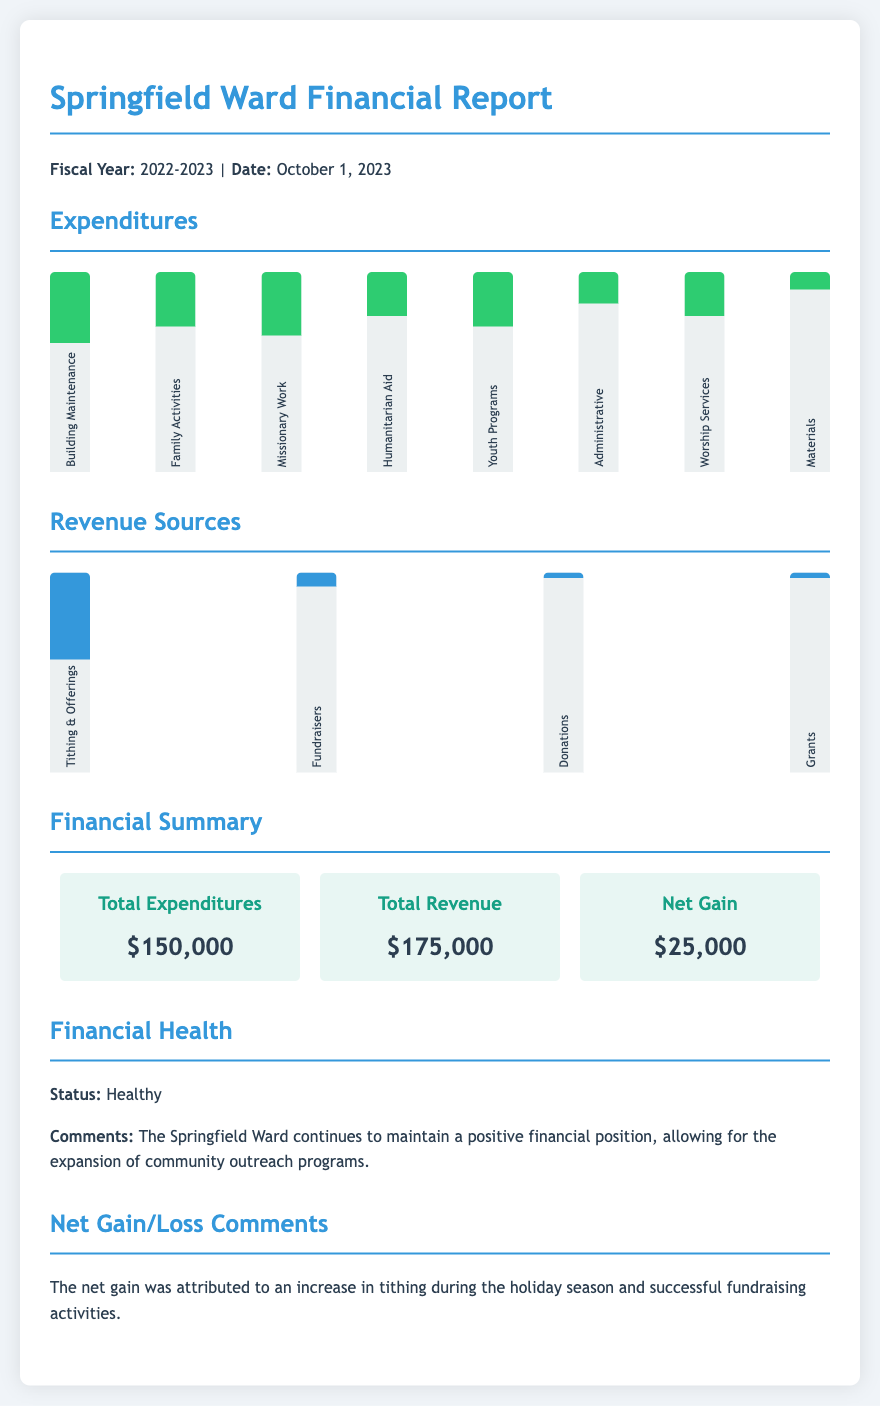What is the fiscal year of the report? The fiscal year is indicated in the document header, showing the period covered by the financial report.
Answer: 2022-2023 What were the total expenditures? The total expenditures are summarized in the financial summary section.
Answer: $150,000 What is the primary source of revenue? The highest revenue source is shown in the revenue sources chart.
Answer: Tithing & Offerings What percentage of the expenditures was spent on Building Maintenance? The chart details the percentage spent on Building Maintenance among other expenditures.
Answer: 60% What is the net gain reported? The net gain is calculated from the total revenue and total expenditures shown in the financial summary.
Answer: $25,000 What is the status of the financial health? The financial health status is explicitly mentioned in the document.
Answer: Healthy What contributed to the net gain? The section comments on the factors leading to the net gain, providing key insights into financial performance.
Answer: Increase in tithing How much revenue did Fundraisers generate? The percentage related to Fundraisers is displayed in the revenue sources chart.
Answer: 8% 